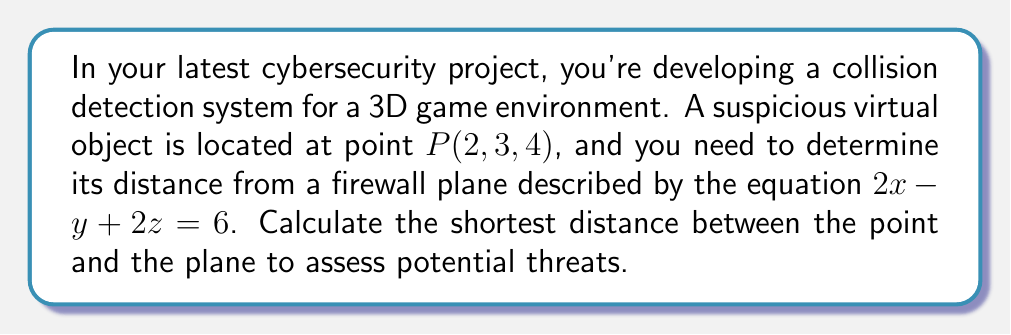What is the answer to this math problem? Let's approach this step-by-step:

1) The general equation for the distance $d$ from a point $(x_0, y_0, z_0)$ to a plane $Ax + By + Cz + D = 0$ is:

   $$d = \frac{|Ax_0 + By_0 + Cz_0 + D|}{\sqrt{A^2 + B^2 + C^2}}$$

2) In our case:
   - Point $P(x_0, y_0, z_0) = (2, 3, 4)$
   - Plane equation: $2x - y + 2z = 6$, which we need to rewrite as $2x - y + 2z - 6 = 0$

3) Comparing with the general form, we have:
   $A = 2$, $B = -1$, $C = 2$, and $D = -6$

4) Now, let's substitute these values into our distance formula:

   $$d = \frac{|2(2) + (-1)(3) + 2(4) + (-6)|}{\sqrt{2^2 + (-1)^2 + 2^2}}$$

5) Simplify the numerator:
   $$d = \frac{|4 - 3 + 8 - 6|}{\sqrt{4 + 1 + 4}}$$
   $$d = \frac{|3|}{\sqrt{9}}$$

6) Simplify further:
   $$d = \frac{3}{3} = 1$$

Therefore, the shortest distance between the point and the plane is 1 unit.
Answer: 1 unit 